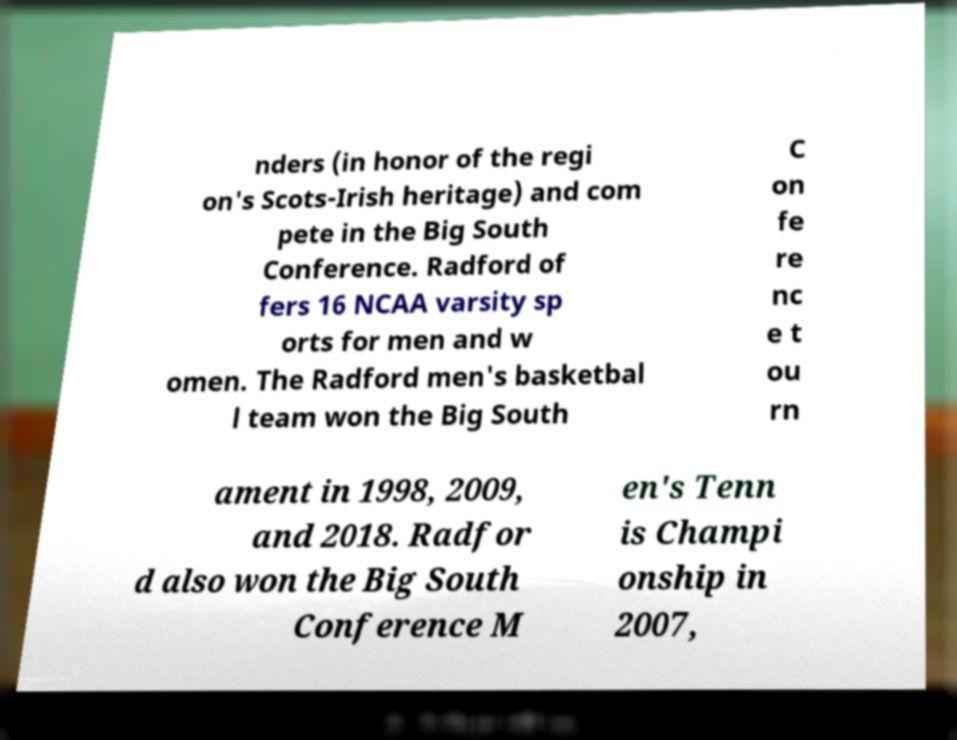Can you accurately transcribe the text from the provided image for me? nders (in honor of the regi on's Scots-Irish heritage) and com pete in the Big South Conference. Radford of fers 16 NCAA varsity sp orts for men and w omen. The Radford men's basketbal l team won the Big South C on fe re nc e t ou rn ament in 1998, 2009, and 2018. Radfor d also won the Big South Conference M en's Tenn is Champi onship in 2007, 